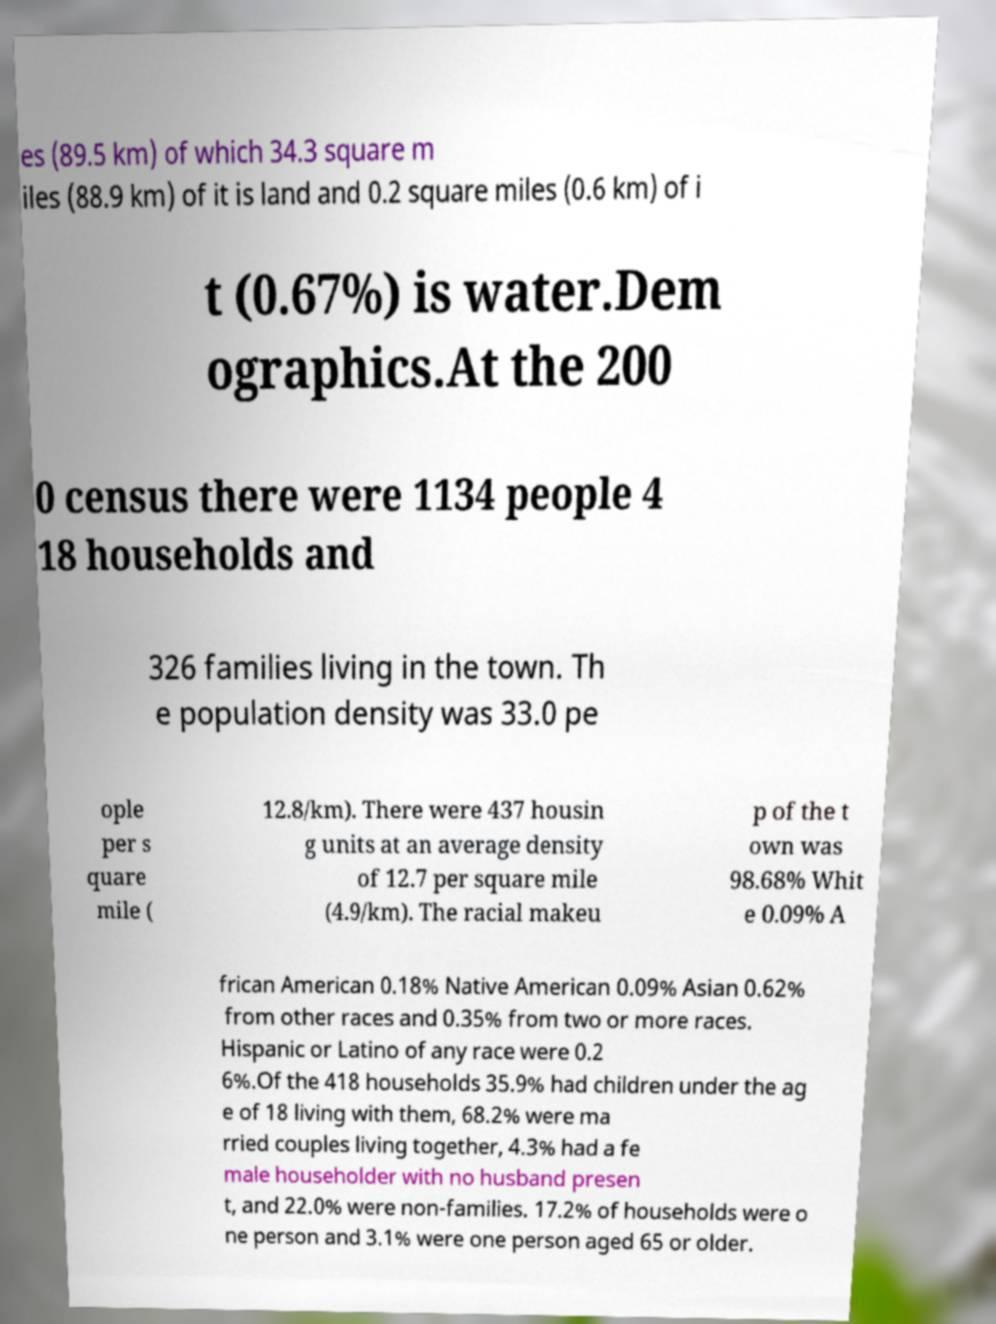Please read and relay the text visible in this image. What does it say? es (89.5 km) of which 34.3 square m iles (88.9 km) of it is land and 0.2 square miles (0.6 km) of i t (0.67%) is water.Dem ographics.At the 200 0 census there were 1134 people 4 18 households and 326 families living in the town. Th e population density was 33.0 pe ople per s quare mile ( 12.8/km). There were 437 housin g units at an average density of 12.7 per square mile (4.9/km). The racial makeu p of the t own was 98.68% Whit e 0.09% A frican American 0.18% Native American 0.09% Asian 0.62% from other races and 0.35% from two or more races. Hispanic or Latino of any race were 0.2 6%.Of the 418 households 35.9% had children under the ag e of 18 living with them, 68.2% were ma rried couples living together, 4.3% had a fe male householder with no husband presen t, and 22.0% were non-families. 17.2% of households were o ne person and 3.1% were one person aged 65 or older. 